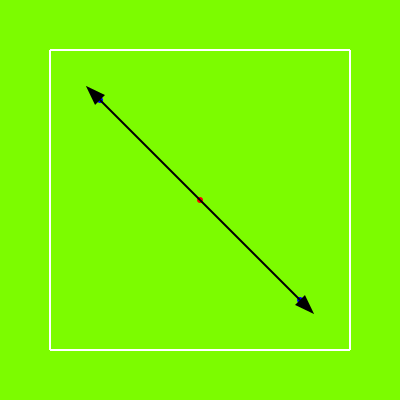In this tactical diagram representing a key aspect of FC Barcelona's Dutch-influenced playing style, two midfielders (blue dots) are moving away from a central player (red dot) to create space. If the pitch is 60 meters wide and 100 meters long, and each midfielder moves 15 meters diagonally from the center, what is the approximate area of the triangle formed by their movements in square meters? To solve this problem, we'll follow these steps:

1. Identify the shape: The movement forms an isosceles triangle.

2. Calculate the base and height of the triangle:
   - The pitch is 60m x 100m
   - Each player moves 15m diagonally

3. Use the Pythagorean theorem to find the base and height:
   $a^2 + b^2 = c^2$, where $c = 15m$
   Let's assume $a = b$ (equal movements in x and y directions)
   $a^2 + a^2 = 15^2$
   $2a^2 = 225$
   $a^2 = 112.5$
   $a = \sqrt{112.5} \approx 10.61m$

4. The base of the triangle is $2 * 10.61m = 21.22m$
   The height of the triangle is also approximately 10.61m

5. Calculate the area using the formula: $A = \frac{1}{2} * base * height$
   $A = \frac{1}{2} * 21.22 * 10.61 \approx 112.5m^2$

Therefore, the area of the triangle formed by the players' movements is approximately 112.5 square meters.
Answer: 112.5 $m^2$ 